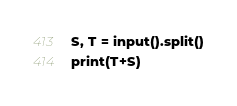<code> <loc_0><loc_0><loc_500><loc_500><_Python_>S, T = input().split()
print(T+S)</code> 